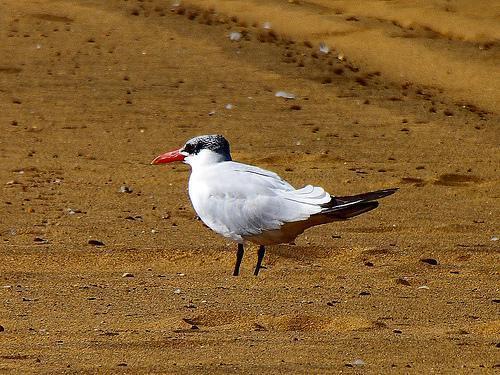How many legs does it have?
Give a very brief answer. 2. 